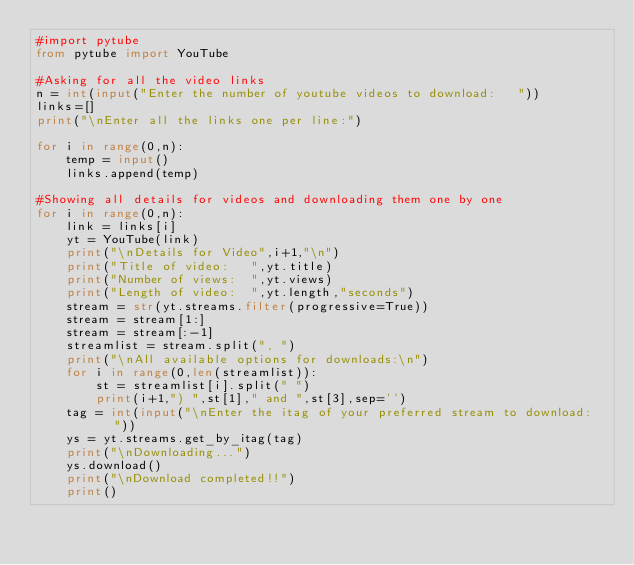Convert code to text. <code><loc_0><loc_0><loc_500><loc_500><_Python_>#import pytube
from pytube import YouTube

#Asking for all the video links
n = int(input("Enter the number of youtube videos to download:   "))
links=[]
print("\nEnter all the links one per line:")

for i in range(0,n):
    temp = input()
    links.append(temp)

#Showing all details for videos and downloading them one by one
for i in range(0,n):
    link = links[i]
    yt = YouTube(link)
    print("\nDetails for Video",i+1,"\n")
    print("Title of video:   ",yt.title)
    print("Number of views:  ",yt.views)
    print("Length of video:  ",yt.length,"seconds")
    stream = str(yt.streams.filter(progressive=True))
    stream = stream[1:]
    stream = stream[:-1]
    streamlist = stream.split(", ")
    print("\nAll available options for downloads:\n")
    for i in range(0,len(streamlist)):
        st = streamlist[i].split(" ")
        print(i+1,") ",st[1]," and ",st[3],sep='')
    tag = int(input("\nEnter the itag of your preferred stream to download:   "))
    ys = yt.streams.get_by_itag(tag)
    print("\nDownloading...")
    ys.download()
    print("\nDownload completed!!")
    print()

</code> 